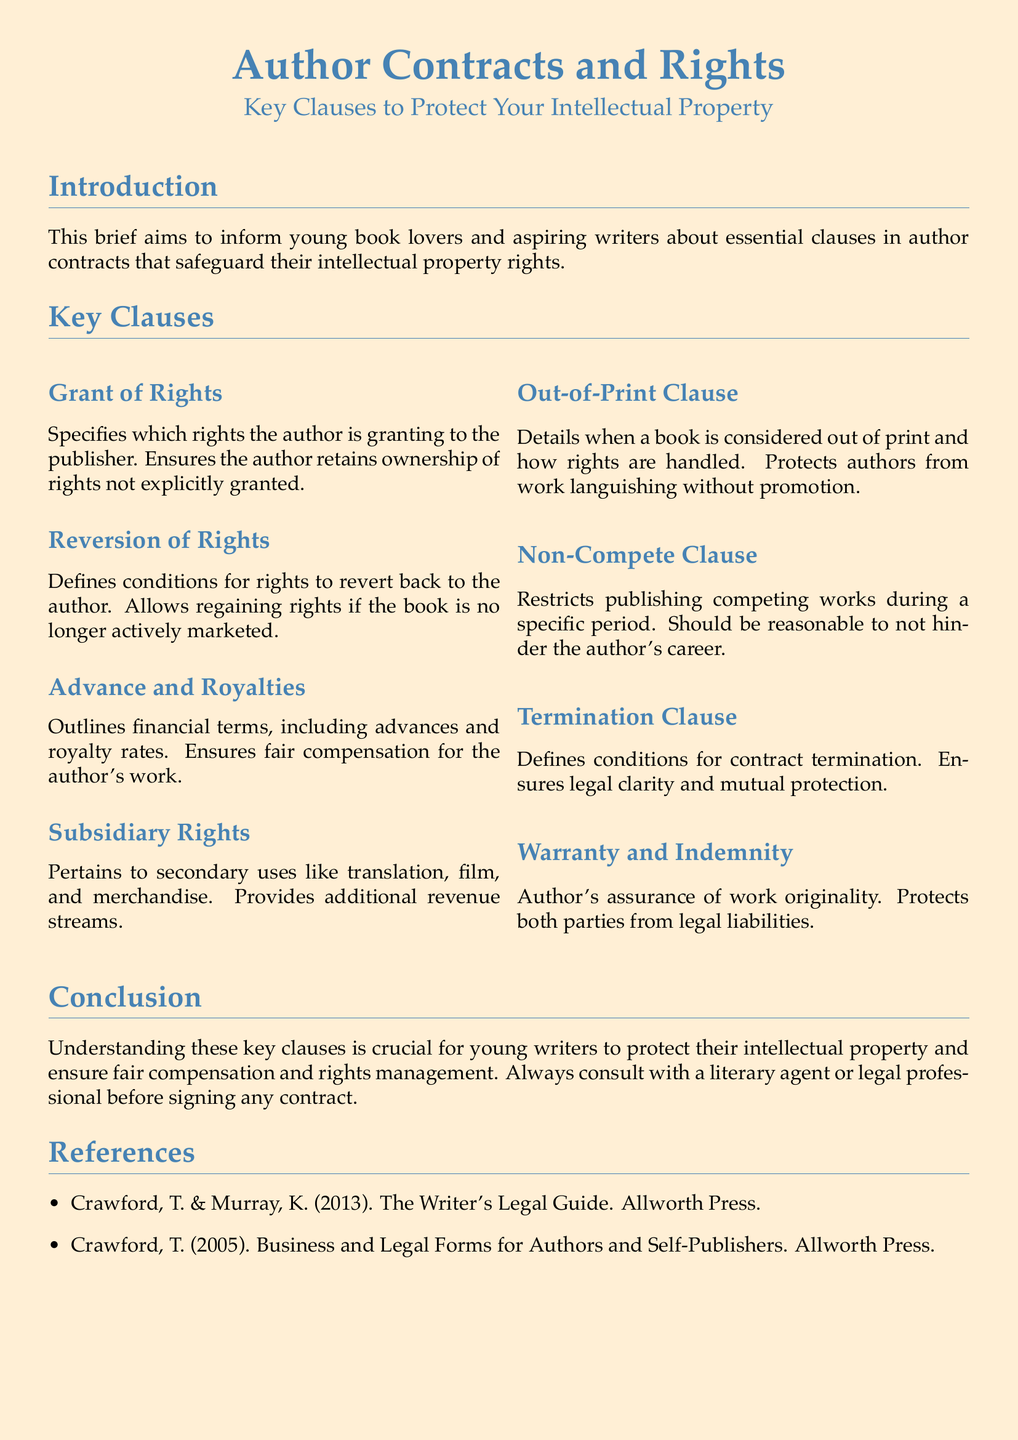What is the main focus of the brief? The brief focuses on key clauses in author contracts that protect intellectual property rights for writers.
Answer: Key clauses in author contracts What clause allows authors to regain rights? This clause specifies the conditions under which rights can revert back to the author, particularly if the book is not actively marketed.
Answer: Reversion of Rights What financial terms are outlined in the contracts? The document specifies the financial arrangement including payments made to the author for their work.
Answer: Advance and Royalties What clause indicates how subsidiary uses are handled? This clause explains how secondary uses, such as film adaptations or merchandise, are managed.
Answer: Subsidiary Rights Which clause protects authors from having their work not promoted? This clause defines when a book is deemed out of print and addresses how rights are handled subsequently.
Answer: Out-of-Print Clause What is a key assurance made by the author? This assurance ensures that the author's work is original and protects against legal liabilities for both parties.
Answer: Warranty and Indemnity What does the Non-Compete Clause restrict? This clause limits the author from publishing competing works during a specified period to protect their market.
Answer: Competing works What should young writers do before signing contracts? The brief advises seeking help from professionals experienced in literary agreements.
Answer: Consult with a literary agent or legal professional 